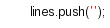<code> <loc_0><loc_0><loc_500><loc_500><_TypeScript_>      lines.push('');</code> 